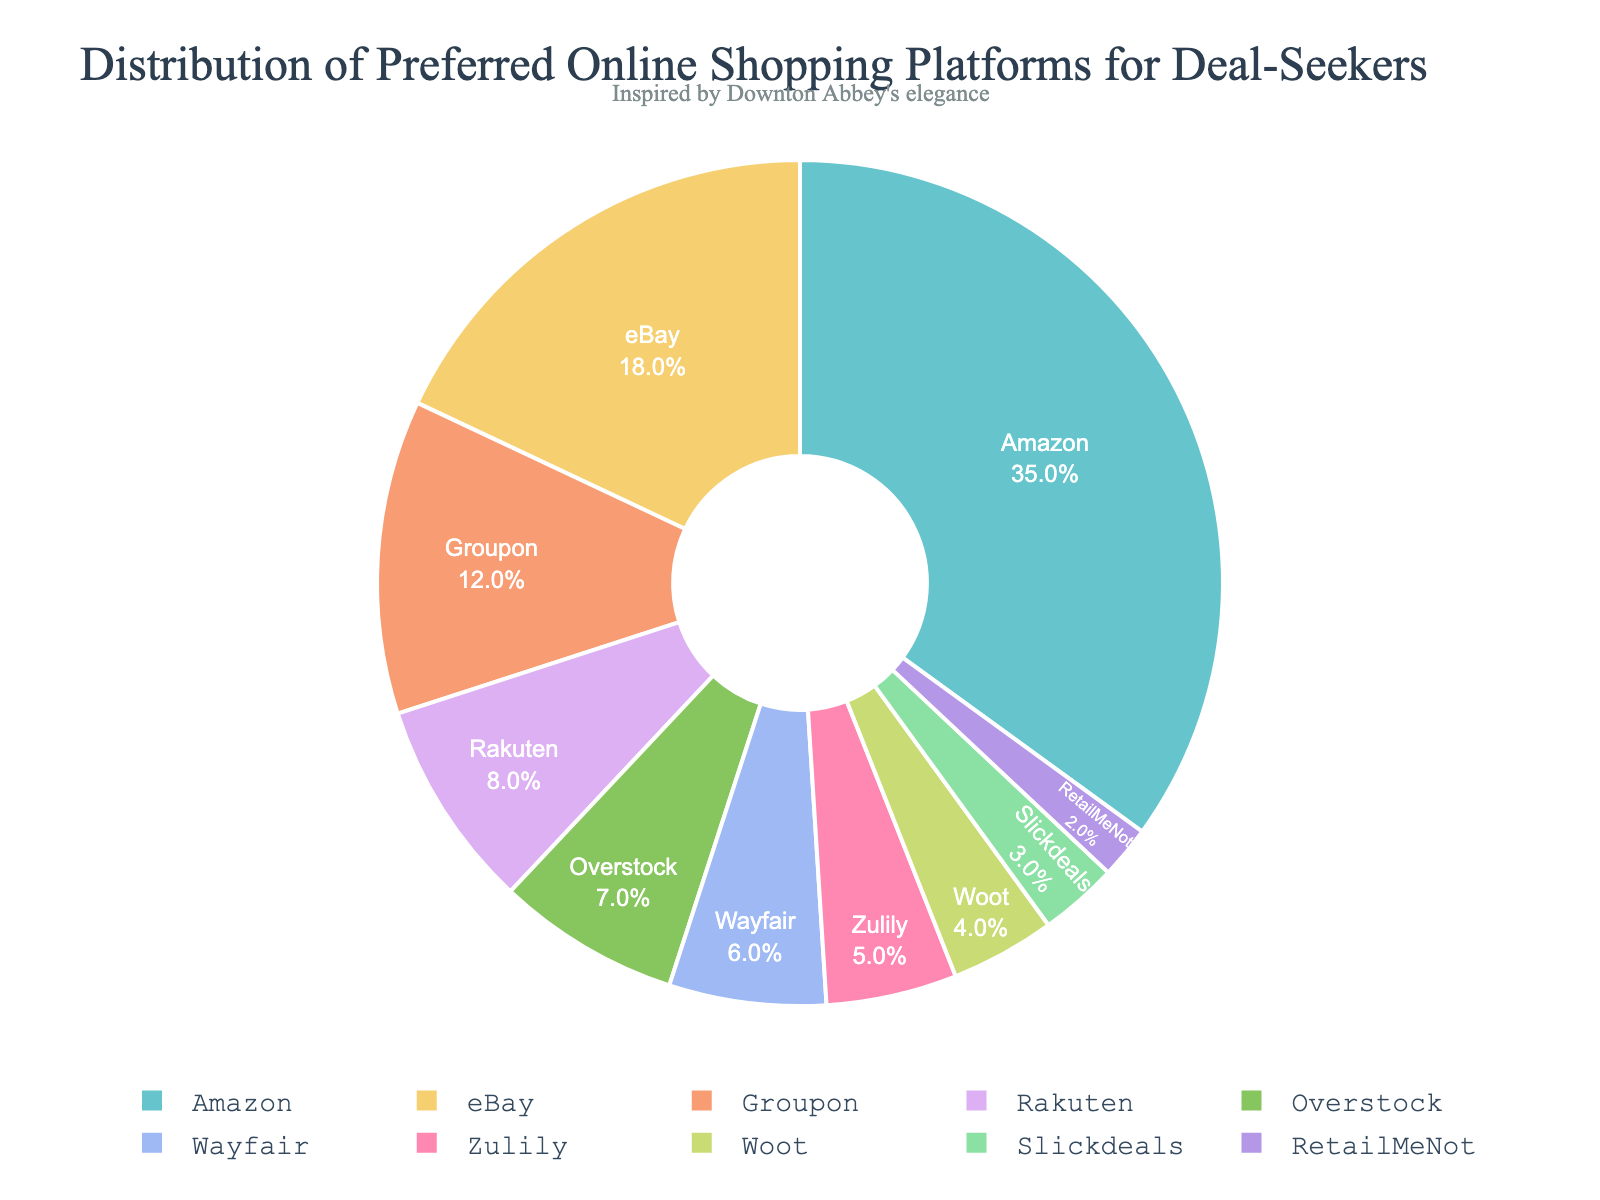What is the most preferred online shopping platform for deal-seekers according to the pie chart? The pie chart shows the distribution of preferred online shopping platforms for deal-seekers, where the largest section represents the most preferred platform. By observing the different portions, "Amazon" has the largest slice.
Answer: Amazon Which platform has the smallest percentage of preference? By examining the pie chart, the smallest slice corresponds to the platform with the smallest percentage. "RetailMeNot" is represented by the smallest section in the chart.
Answer: RetailMeNot How much more percentage does Amazon have over eBay? From the pie chart, Amazon has 35% and eBay has 18%. The difference between these two percentages is calculated as 35% - 18%.
Answer: 17% What is the combined preference percentage for Groupon and Rakuten? The pie chart shows Groupon at 12% and Rakuten at 8%. To find the combined percentage, we sum these values: 12% + 8%.
Answer: 20% What is the percentage difference between Wayfair and Zulily? Wayfair is shown to have a 6% preference while Zulily has 5%. The difference between these percentages is calculated as 6% - 5%.
Answer: 1% Which platform is preferred by more people: Overstock or Wayfair? By looking at the sections of the pie chart, Overstock is shown to have a 7% preference while Wayfair has a 6% preference. This indicates Overstock is preferred by more people.
Answer: Overstock What is the total percentage for platforms with a preference of 5% or less? Platforms with 5% or less are Zulily (5%), Woot (4%), Slickdeals (3%), and RetailMeNot (2%). Summing these values gives: 5% + 4% + 3% + 2% = 14%.
Answer: 14% Is the preference for Slickdeals greater than, less than, or equal to 5%? By analyzing the pie chart, Slickdeals has been represented with a 3% preference. Therefore, Slickdeals is less than 5%.
Answer: Less than Which platforms have a combined preference percentage less than Groupon? Groupon has a 12% preference. Platforms with preferences less than Groupon are Rakuten (8%), Overstock (7%), Wayfair (6%), Zulily (5%), Woot (4%), Slickdeals (3%), and RetailMeNot (2%). The sum of their preferences: 8% + 7% + 6% + 5% + 4% + 3% + 2% = 35%. Anything over 12% individually is not less than Groupon.
Answer: Multiple platforms Based on the pie chart, which legend orientation is used? The pie chart’s legend orientation is described in the data description, stating it is horizontal and situated at the bottom center. Observing the location of the legend further confirms this.
Answer: Horizontal 